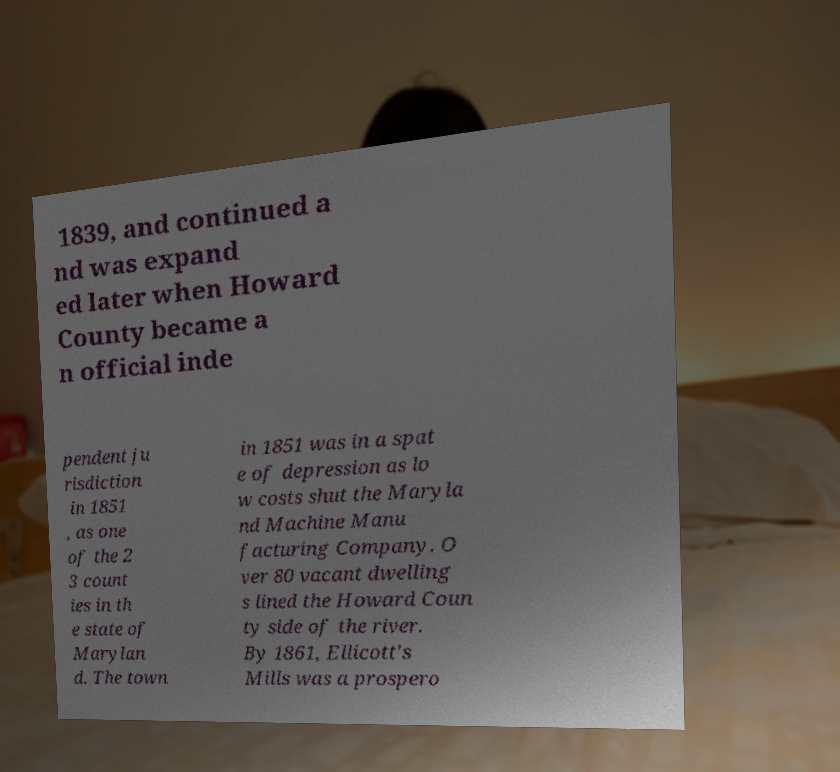I need the written content from this picture converted into text. Can you do that? 1839, and continued a nd was expand ed later when Howard County became a n official inde pendent ju risdiction in 1851 , as one of the 2 3 count ies in th e state of Marylan d. The town in 1851 was in a spat e of depression as lo w costs shut the Maryla nd Machine Manu facturing Company. O ver 80 vacant dwelling s lined the Howard Coun ty side of the river. By 1861, Ellicott's Mills was a prospero 